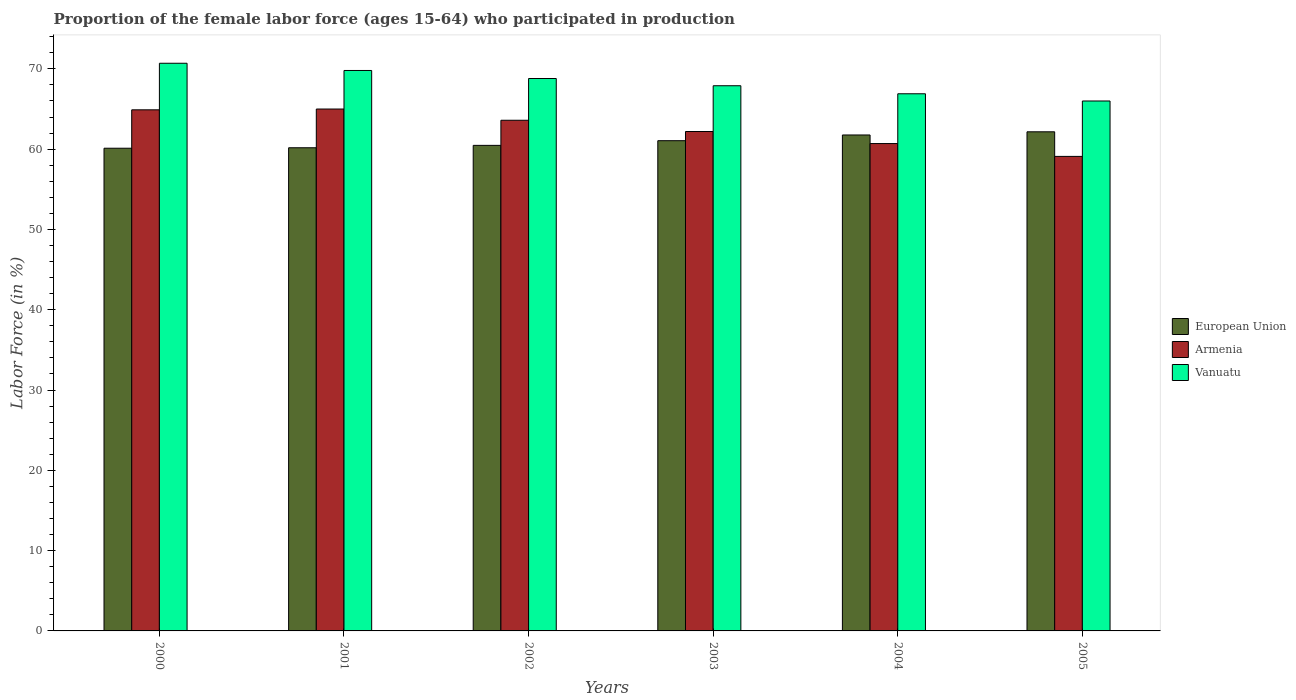How many groups of bars are there?
Make the answer very short. 6. How many bars are there on the 4th tick from the left?
Provide a short and direct response. 3. What is the proportion of the female labor force who participated in production in Armenia in 2000?
Provide a short and direct response. 64.9. Across all years, what is the maximum proportion of the female labor force who participated in production in Vanuatu?
Keep it short and to the point. 70.7. Across all years, what is the minimum proportion of the female labor force who participated in production in European Union?
Keep it short and to the point. 60.12. In which year was the proportion of the female labor force who participated in production in European Union maximum?
Ensure brevity in your answer.  2005. What is the total proportion of the female labor force who participated in production in European Union in the graph?
Offer a very short reply. 365.76. What is the difference between the proportion of the female labor force who participated in production in European Union in 2004 and that in 2005?
Offer a terse response. -0.39. What is the difference between the proportion of the female labor force who participated in production in Vanuatu in 2001 and the proportion of the female labor force who participated in production in Armenia in 2002?
Offer a terse response. 6.2. What is the average proportion of the female labor force who participated in production in European Union per year?
Your answer should be compact. 60.96. In the year 2004, what is the difference between the proportion of the female labor force who participated in production in Vanuatu and proportion of the female labor force who participated in production in European Union?
Offer a terse response. 5.13. What is the ratio of the proportion of the female labor force who participated in production in Armenia in 2002 to that in 2003?
Your response must be concise. 1.02. Is the proportion of the female labor force who participated in production in European Union in 2004 less than that in 2005?
Ensure brevity in your answer.  Yes. What is the difference between the highest and the second highest proportion of the female labor force who participated in production in European Union?
Keep it short and to the point. 0.39. What is the difference between the highest and the lowest proportion of the female labor force who participated in production in Vanuatu?
Provide a short and direct response. 4.7. Is the sum of the proportion of the female labor force who participated in production in Armenia in 2000 and 2005 greater than the maximum proportion of the female labor force who participated in production in European Union across all years?
Keep it short and to the point. Yes. What does the 1st bar from the right in 2004 represents?
Provide a succinct answer. Vanuatu. How many years are there in the graph?
Provide a succinct answer. 6. Are the values on the major ticks of Y-axis written in scientific E-notation?
Keep it short and to the point. No. Does the graph contain grids?
Keep it short and to the point. No. What is the title of the graph?
Make the answer very short. Proportion of the female labor force (ages 15-64) who participated in production. What is the label or title of the Y-axis?
Your answer should be compact. Labor Force (in %). What is the Labor Force (in %) in European Union in 2000?
Your answer should be very brief. 60.12. What is the Labor Force (in %) of Armenia in 2000?
Provide a succinct answer. 64.9. What is the Labor Force (in %) of Vanuatu in 2000?
Give a very brief answer. 70.7. What is the Labor Force (in %) of European Union in 2001?
Give a very brief answer. 60.18. What is the Labor Force (in %) in Vanuatu in 2001?
Offer a very short reply. 69.8. What is the Labor Force (in %) of European Union in 2002?
Provide a short and direct response. 60.47. What is the Labor Force (in %) of Armenia in 2002?
Ensure brevity in your answer.  63.6. What is the Labor Force (in %) of Vanuatu in 2002?
Give a very brief answer. 68.8. What is the Labor Force (in %) in European Union in 2003?
Provide a succinct answer. 61.06. What is the Labor Force (in %) in Armenia in 2003?
Your response must be concise. 62.2. What is the Labor Force (in %) in Vanuatu in 2003?
Keep it short and to the point. 67.9. What is the Labor Force (in %) of European Union in 2004?
Your answer should be compact. 61.77. What is the Labor Force (in %) in Armenia in 2004?
Your answer should be very brief. 60.7. What is the Labor Force (in %) in Vanuatu in 2004?
Ensure brevity in your answer.  66.9. What is the Labor Force (in %) of European Union in 2005?
Offer a terse response. 62.16. What is the Labor Force (in %) in Armenia in 2005?
Make the answer very short. 59.1. What is the Labor Force (in %) of Vanuatu in 2005?
Give a very brief answer. 66. Across all years, what is the maximum Labor Force (in %) in European Union?
Give a very brief answer. 62.16. Across all years, what is the maximum Labor Force (in %) of Armenia?
Offer a terse response. 65. Across all years, what is the maximum Labor Force (in %) of Vanuatu?
Provide a short and direct response. 70.7. Across all years, what is the minimum Labor Force (in %) in European Union?
Your answer should be compact. 60.12. Across all years, what is the minimum Labor Force (in %) of Armenia?
Make the answer very short. 59.1. Across all years, what is the minimum Labor Force (in %) in Vanuatu?
Your response must be concise. 66. What is the total Labor Force (in %) of European Union in the graph?
Your answer should be very brief. 365.76. What is the total Labor Force (in %) in Armenia in the graph?
Give a very brief answer. 375.5. What is the total Labor Force (in %) of Vanuatu in the graph?
Keep it short and to the point. 410.1. What is the difference between the Labor Force (in %) in European Union in 2000 and that in 2001?
Provide a succinct answer. -0.06. What is the difference between the Labor Force (in %) in Armenia in 2000 and that in 2001?
Your answer should be compact. -0.1. What is the difference between the Labor Force (in %) in European Union in 2000 and that in 2002?
Provide a short and direct response. -0.36. What is the difference between the Labor Force (in %) of Armenia in 2000 and that in 2002?
Your answer should be very brief. 1.3. What is the difference between the Labor Force (in %) in European Union in 2000 and that in 2003?
Make the answer very short. -0.94. What is the difference between the Labor Force (in %) of Vanuatu in 2000 and that in 2003?
Your response must be concise. 2.8. What is the difference between the Labor Force (in %) of European Union in 2000 and that in 2004?
Make the answer very short. -1.65. What is the difference between the Labor Force (in %) in Vanuatu in 2000 and that in 2004?
Ensure brevity in your answer.  3.8. What is the difference between the Labor Force (in %) of European Union in 2000 and that in 2005?
Ensure brevity in your answer.  -2.05. What is the difference between the Labor Force (in %) of Armenia in 2000 and that in 2005?
Your answer should be compact. 5.8. What is the difference between the Labor Force (in %) in European Union in 2001 and that in 2002?
Keep it short and to the point. -0.3. What is the difference between the Labor Force (in %) in Armenia in 2001 and that in 2002?
Keep it short and to the point. 1.4. What is the difference between the Labor Force (in %) of European Union in 2001 and that in 2003?
Keep it short and to the point. -0.88. What is the difference between the Labor Force (in %) of Armenia in 2001 and that in 2003?
Your answer should be very brief. 2.8. What is the difference between the Labor Force (in %) in European Union in 2001 and that in 2004?
Provide a short and direct response. -1.59. What is the difference between the Labor Force (in %) of Vanuatu in 2001 and that in 2004?
Offer a very short reply. 2.9. What is the difference between the Labor Force (in %) of European Union in 2001 and that in 2005?
Offer a very short reply. -1.99. What is the difference between the Labor Force (in %) in European Union in 2002 and that in 2003?
Offer a very short reply. -0.58. What is the difference between the Labor Force (in %) in Armenia in 2002 and that in 2003?
Give a very brief answer. 1.4. What is the difference between the Labor Force (in %) in European Union in 2002 and that in 2004?
Your answer should be compact. -1.3. What is the difference between the Labor Force (in %) in Armenia in 2002 and that in 2004?
Give a very brief answer. 2.9. What is the difference between the Labor Force (in %) in European Union in 2002 and that in 2005?
Offer a terse response. -1.69. What is the difference between the Labor Force (in %) of Vanuatu in 2002 and that in 2005?
Offer a terse response. 2.8. What is the difference between the Labor Force (in %) in European Union in 2003 and that in 2004?
Offer a terse response. -0.71. What is the difference between the Labor Force (in %) in Armenia in 2003 and that in 2004?
Keep it short and to the point. 1.5. What is the difference between the Labor Force (in %) in European Union in 2003 and that in 2005?
Give a very brief answer. -1.11. What is the difference between the Labor Force (in %) of Vanuatu in 2003 and that in 2005?
Provide a short and direct response. 1.9. What is the difference between the Labor Force (in %) of European Union in 2004 and that in 2005?
Your answer should be compact. -0.39. What is the difference between the Labor Force (in %) of Armenia in 2004 and that in 2005?
Provide a succinct answer. 1.6. What is the difference between the Labor Force (in %) in Vanuatu in 2004 and that in 2005?
Offer a very short reply. 0.9. What is the difference between the Labor Force (in %) of European Union in 2000 and the Labor Force (in %) of Armenia in 2001?
Your answer should be very brief. -4.88. What is the difference between the Labor Force (in %) of European Union in 2000 and the Labor Force (in %) of Vanuatu in 2001?
Give a very brief answer. -9.68. What is the difference between the Labor Force (in %) in European Union in 2000 and the Labor Force (in %) in Armenia in 2002?
Ensure brevity in your answer.  -3.48. What is the difference between the Labor Force (in %) in European Union in 2000 and the Labor Force (in %) in Vanuatu in 2002?
Ensure brevity in your answer.  -8.68. What is the difference between the Labor Force (in %) of European Union in 2000 and the Labor Force (in %) of Armenia in 2003?
Give a very brief answer. -2.08. What is the difference between the Labor Force (in %) in European Union in 2000 and the Labor Force (in %) in Vanuatu in 2003?
Offer a terse response. -7.78. What is the difference between the Labor Force (in %) in European Union in 2000 and the Labor Force (in %) in Armenia in 2004?
Offer a very short reply. -0.58. What is the difference between the Labor Force (in %) in European Union in 2000 and the Labor Force (in %) in Vanuatu in 2004?
Provide a short and direct response. -6.78. What is the difference between the Labor Force (in %) of European Union in 2000 and the Labor Force (in %) of Armenia in 2005?
Provide a short and direct response. 1.02. What is the difference between the Labor Force (in %) of European Union in 2000 and the Labor Force (in %) of Vanuatu in 2005?
Your response must be concise. -5.88. What is the difference between the Labor Force (in %) in Armenia in 2000 and the Labor Force (in %) in Vanuatu in 2005?
Give a very brief answer. -1.1. What is the difference between the Labor Force (in %) of European Union in 2001 and the Labor Force (in %) of Armenia in 2002?
Make the answer very short. -3.42. What is the difference between the Labor Force (in %) in European Union in 2001 and the Labor Force (in %) in Vanuatu in 2002?
Make the answer very short. -8.62. What is the difference between the Labor Force (in %) of European Union in 2001 and the Labor Force (in %) of Armenia in 2003?
Provide a short and direct response. -2.02. What is the difference between the Labor Force (in %) of European Union in 2001 and the Labor Force (in %) of Vanuatu in 2003?
Provide a short and direct response. -7.72. What is the difference between the Labor Force (in %) of Armenia in 2001 and the Labor Force (in %) of Vanuatu in 2003?
Make the answer very short. -2.9. What is the difference between the Labor Force (in %) of European Union in 2001 and the Labor Force (in %) of Armenia in 2004?
Keep it short and to the point. -0.52. What is the difference between the Labor Force (in %) in European Union in 2001 and the Labor Force (in %) in Vanuatu in 2004?
Keep it short and to the point. -6.72. What is the difference between the Labor Force (in %) in Armenia in 2001 and the Labor Force (in %) in Vanuatu in 2004?
Give a very brief answer. -1.9. What is the difference between the Labor Force (in %) of European Union in 2001 and the Labor Force (in %) of Armenia in 2005?
Provide a short and direct response. 1.08. What is the difference between the Labor Force (in %) of European Union in 2001 and the Labor Force (in %) of Vanuatu in 2005?
Ensure brevity in your answer.  -5.82. What is the difference between the Labor Force (in %) in Armenia in 2001 and the Labor Force (in %) in Vanuatu in 2005?
Your response must be concise. -1. What is the difference between the Labor Force (in %) of European Union in 2002 and the Labor Force (in %) of Armenia in 2003?
Your response must be concise. -1.73. What is the difference between the Labor Force (in %) in European Union in 2002 and the Labor Force (in %) in Vanuatu in 2003?
Provide a short and direct response. -7.43. What is the difference between the Labor Force (in %) in Armenia in 2002 and the Labor Force (in %) in Vanuatu in 2003?
Make the answer very short. -4.3. What is the difference between the Labor Force (in %) in European Union in 2002 and the Labor Force (in %) in Armenia in 2004?
Offer a very short reply. -0.23. What is the difference between the Labor Force (in %) in European Union in 2002 and the Labor Force (in %) in Vanuatu in 2004?
Your answer should be compact. -6.43. What is the difference between the Labor Force (in %) of Armenia in 2002 and the Labor Force (in %) of Vanuatu in 2004?
Your answer should be very brief. -3.3. What is the difference between the Labor Force (in %) in European Union in 2002 and the Labor Force (in %) in Armenia in 2005?
Provide a short and direct response. 1.37. What is the difference between the Labor Force (in %) in European Union in 2002 and the Labor Force (in %) in Vanuatu in 2005?
Your response must be concise. -5.53. What is the difference between the Labor Force (in %) of European Union in 2003 and the Labor Force (in %) of Armenia in 2004?
Offer a terse response. 0.36. What is the difference between the Labor Force (in %) of European Union in 2003 and the Labor Force (in %) of Vanuatu in 2004?
Provide a succinct answer. -5.84. What is the difference between the Labor Force (in %) in Armenia in 2003 and the Labor Force (in %) in Vanuatu in 2004?
Your response must be concise. -4.7. What is the difference between the Labor Force (in %) in European Union in 2003 and the Labor Force (in %) in Armenia in 2005?
Provide a succinct answer. 1.96. What is the difference between the Labor Force (in %) in European Union in 2003 and the Labor Force (in %) in Vanuatu in 2005?
Give a very brief answer. -4.94. What is the difference between the Labor Force (in %) of European Union in 2004 and the Labor Force (in %) of Armenia in 2005?
Ensure brevity in your answer.  2.67. What is the difference between the Labor Force (in %) in European Union in 2004 and the Labor Force (in %) in Vanuatu in 2005?
Your answer should be compact. -4.23. What is the difference between the Labor Force (in %) of Armenia in 2004 and the Labor Force (in %) of Vanuatu in 2005?
Give a very brief answer. -5.3. What is the average Labor Force (in %) of European Union per year?
Give a very brief answer. 60.96. What is the average Labor Force (in %) in Armenia per year?
Your answer should be compact. 62.58. What is the average Labor Force (in %) in Vanuatu per year?
Make the answer very short. 68.35. In the year 2000, what is the difference between the Labor Force (in %) in European Union and Labor Force (in %) in Armenia?
Give a very brief answer. -4.78. In the year 2000, what is the difference between the Labor Force (in %) of European Union and Labor Force (in %) of Vanuatu?
Your response must be concise. -10.58. In the year 2000, what is the difference between the Labor Force (in %) of Armenia and Labor Force (in %) of Vanuatu?
Make the answer very short. -5.8. In the year 2001, what is the difference between the Labor Force (in %) of European Union and Labor Force (in %) of Armenia?
Your answer should be very brief. -4.82. In the year 2001, what is the difference between the Labor Force (in %) in European Union and Labor Force (in %) in Vanuatu?
Offer a terse response. -9.62. In the year 2002, what is the difference between the Labor Force (in %) of European Union and Labor Force (in %) of Armenia?
Your answer should be very brief. -3.13. In the year 2002, what is the difference between the Labor Force (in %) of European Union and Labor Force (in %) of Vanuatu?
Ensure brevity in your answer.  -8.33. In the year 2003, what is the difference between the Labor Force (in %) in European Union and Labor Force (in %) in Armenia?
Keep it short and to the point. -1.14. In the year 2003, what is the difference between the Labor Force (in %) in European Union and Labor Force (in %) in Vanuatu?
Keep it short and to the point. -6.84. In the year 2003, what is the difference between the Labor Force (in %) in Armenia and Labor Force (in %) in Vanuatu?
Your answer should be compact. -5.7. In the year 2004, what is the difference between the Labor Force (in %) in European Union and Labor Force (in %) in Armenia?
Your answer should be very brief. 1.07. In the year 2004, what is the difference between the Labor Force (in %) of European Union and Labor Force (in %) of Vanuatu?
Provide a succinct answer. -5.13. In the year 2005, what is the difference between the Labor Force (in %) of European Union and Labor Force (in %) of Armenia?
Ensure brevity in your answer.  3.06. In the year 2005, what is the difference between the Labor Force (in %) in European Union and Labor Force (in %) in Vanuatu?
Provide a short and direct response. -3.84. What is the ratio of the Labor Force (in %) in Vanuatu in 2000 to that in 2001?
Keep it short and to the point. 1.01. What is the ratio of the Labor Force (in %) of European Union in 2000 to that in 2002?
Offer a very short reply. 0.99. What is the ratio of the Labor Force (in %) in Armenia in 2000 to that in 2002?
Your answer should be compact. 1.02. What is the ratio of the Labor Force (in %) in Vanuatu in 2000 to that in 2002?
Your answer should be very brief. 1.03. What is the ratio of the Labor Force (in %) in European Union in 2000 to that in 2003?
Provide a short and direct response. 0.98. What is the ratio of the Labor Force (in %) of Armenia in 2000 to that in 2003?
Offer a terse response. 1.04. What is the ratio of the Labor Force (in %) in Vanuatu in 2000 to that in 2003?
Provide a succinct answer. 1.04. What is the ratio of the Labor Force (in %) of European Union in 2000 to that in 2004?
Make the answer very short. 0.97. What is the ratio of the Labor Force (in %) in Armenia in 2000 to that in 2004?
Provide a short and direct response. 1.07. What is the ratio of the Labor Force (in %) of Vanuatu in 2000 to that in 2004?
Keep it short and to the point. 1.06. What is the ratio of the Labor Force (in %) of European Union in 2000 to that in 2005?
Provide a succinct answer. 0.97. What is the ratio of the Labor Force (in %) of Armenia in 2000 to that in 2005?
Offer a very short reply. 1.1. What is the ratio of the Labor Force (in %) in Vanuatu in 2000 to that in 2005?
Give a very brief answer. 1.07. What is the ratio of the Labor Force (in %) in Armenia in 2001 to that in 2002?
Your answer should be very brief. 1.02. What is the ratio of the Labor Force (in %) of Vanuatu in 2001 to that in 2002?
Ensure brevity in your answer.  1.01. What is the ratio of the Labor Force (in %) in European Union in 2001 to that in 2003?
Your response must be concise. 0.99. What is the ratio of the Labor Force (in %) in Armenia in 2001 to that in 2003?
Offer a terse response. 1.04. What is the ratio of the Labor Force (in %) in Vanuatu in 2001 to that in 2003?
Provide a succinct answer. 1.03. What is the ratio of the Labor Force (in %) of European Union in 2001 to that in 2004?
Your answer should be very brief. 0.97. What is the ratio of the Labor Force (in %) in Armenia in 2001 to that in 2004?
Provide a short and direct response. 1.07. What is the ratio of the Labor Force (in %) in Vanuatu in 2001 to that in 2004?
Your answer should be compact. 1.04. What is the ratio of the Labor Force (in %) in Armenia in 2001 to that in 2005?
Your answer should be compact. 1.1. What is the ratio of the Labor Force (in %) in Vanuatu in 2001 to that in 2005?
Offer a very short reply. 1.06. What is the ratio of the Labor Force (in %) in Armenia in 2002 to that in 2003?
Keep it short and to the point. 1.02. What is the ratio of the Labor Force (in %) in Vanuatu in 2002 to that in 2003?
Make the answer very short. 1.01. What is the ratio of the Labor Force (in %) in Armenia in 2002 to that in 2004?
Keep it short and to the point. 1.05. What is the ratio of the Labor Force (in %) of Vanuatu in 2002 to that in 2004?
Your answer should be very brief. 1.03. What is the ratio of the Labor Force (in %) of European Union in 2002 to that in 2005?
Offer a terse response. 0.97. What is the ratio of the Labor Force (in %) in Armenia in 2002 to that in 2005?
Offer a terse response. 1.08. What is the ratio of the Labor Force (in %) of Vanuatu in 2002 to that in 2005?
Provide a succinct answer. 1.04. What is the ratio of the Labor Force (in %) of Armenia in 2003 to that in 2004?
Your answer should be compact. 1.02. What is the ratio of the Labor Force (in %) of Vanuatu in 2003 to that in 2004?
Your answer should be compact. 1.01. What is the ratio of the Labor Force (in %) in European Union in 2003 to that in 2005?
Your answer should be very brief. 0.98. What is the ratio of the Labor Force (in %) in Armenia in 2003 to that in 2005?
Your response must be concise. 1.05. What is the ratio of the Labor Force (in %) in Vanuatu in 2003 to that in 2005?
Your answer should be compact. 1.03. What is the ratio of the Labor Force (in %) of European Union in 2004 to that in 2005?
Your answer should be compact. 0.99. What is the ratio of the Labor Force (in %) in Armenia in 2004 to that in 2005?
Keep it short and to the point. 1.03. What is the ratio of the Labor Force (in %) of Vanuatu in 2004 to that in 2005?
Give a very brief answer. 1.01. What is the difference between the highest and the second highest Labor Force (in %) of European Union?
Your answer should be compact. 0.39. What is the difference between the highest and the second highest Labor Force (in %) in Armenia?
Your answer should be very brief. 0.1. What is the difference between the highest and the lowest Labor Force (in %) in European Union?
Your answer should be compact. 2.05. What is the difference between the highest and the lowest Labor Force (in %) of Vanuatu?
Provide a succinct answer. 4.7. 